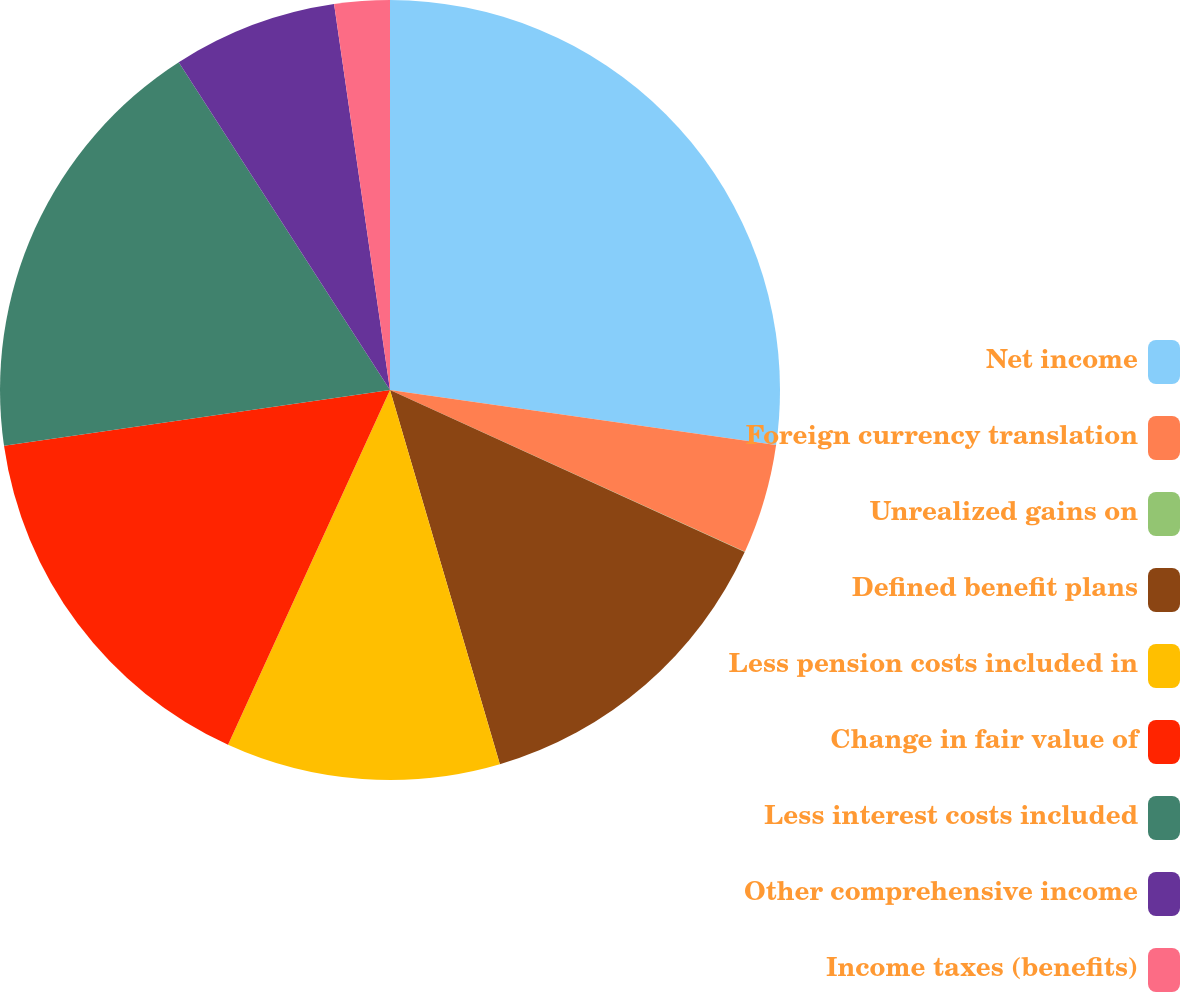Convert chart. <chart><loc_0><loc_0><loc_500><loc_500><pie_chart><fcel>Net income<fcel>Foreign currency translation<fcel>Unrealized gains on<fcel>Defined benefit plans<fcel>Less pension costs included in<fcel>Change in fair value of<fcel>Less interest costs included<fcel>Other comprehensive income<fcel>Income taxes (benefits)<nl><fcel>27.25%<fcel>4.55%<fcel>0.02%<fcel>13.63%<fcel>11.36%<fcel>15.9%<fcel>18.17%<fcel>6.82%<fcel>2.29%<nl></chart> 